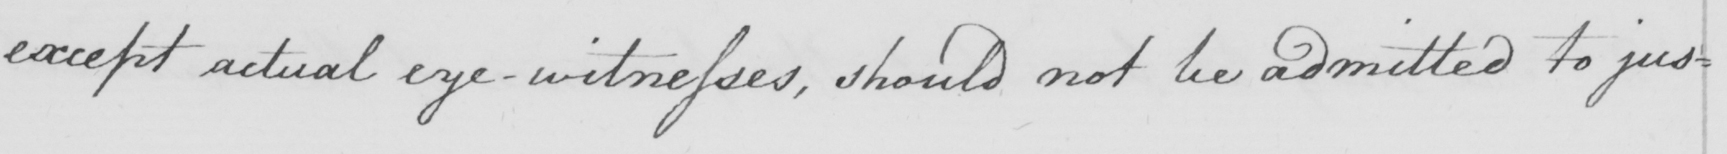Please transcribe the handwritten text in this image. except actual eye-witnesses , should not be admitted to jus= 